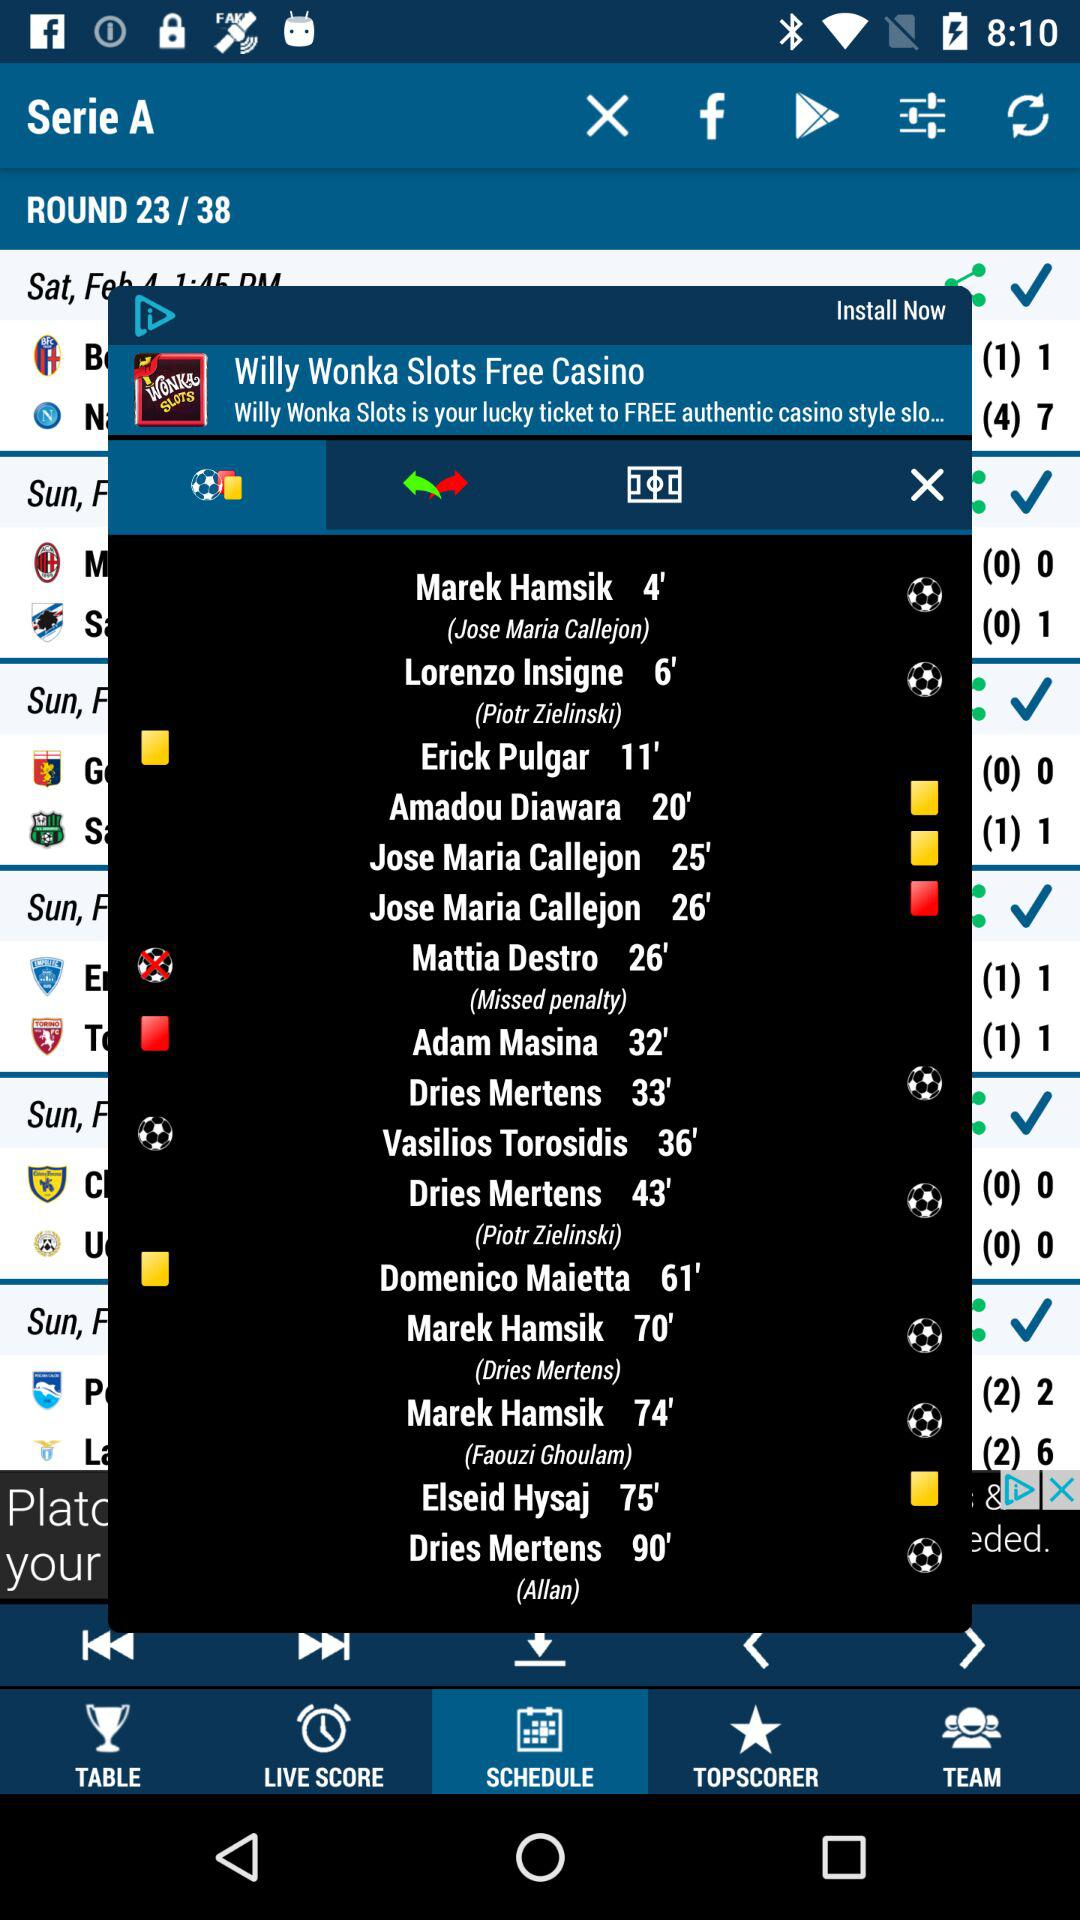What is the name of the tournament? The name of the tournament is "Serie A". 